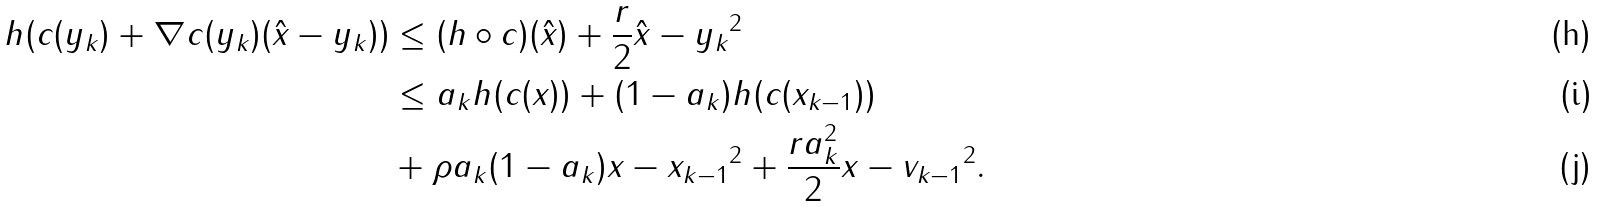<formula> <loc_0><loc_0><loc_500><loc_500>h ( c ( y _ { k } ) + \nabla c ( y _ { k } ) ( \hat { x } - y _ { k } ) ) & \leq ( h \circ c ) ( \hat { x } ) + \frac { r } { 2 } \| \hat { x } - y _ { k } \| ^ { 2 } \\ & \leq a _ { k } h ( c ( x ) ) + ( 1 - a _ { k } ) h ( c ( x _ { k - 1 } ) ) \\ & + \rho a _ { k } ( 1 - a _ { k } ) \| x - x _ { k - 1 } \| ^ { 2 } + \frac { r a _ { k } ^ { 2 } } { 2 } \| x - v _ { k - 1 } \| ^ { 2 } .</formula> 